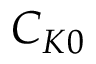<formula> <loc_0><loc_0><loc_500><loc_500>C _ { K 0 }</formula> 